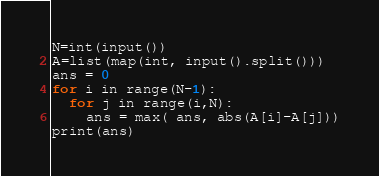<code> <loc_0><loc_0><loc_500><loc_500><_Python_>N=int(input())
A=list(map(int, input().split()))
ans = 0
for i in range(N-1):
  for j in range(i,N):
    ans = max( ans, abs(A[i]-A[j]))
print(ans)</code> 